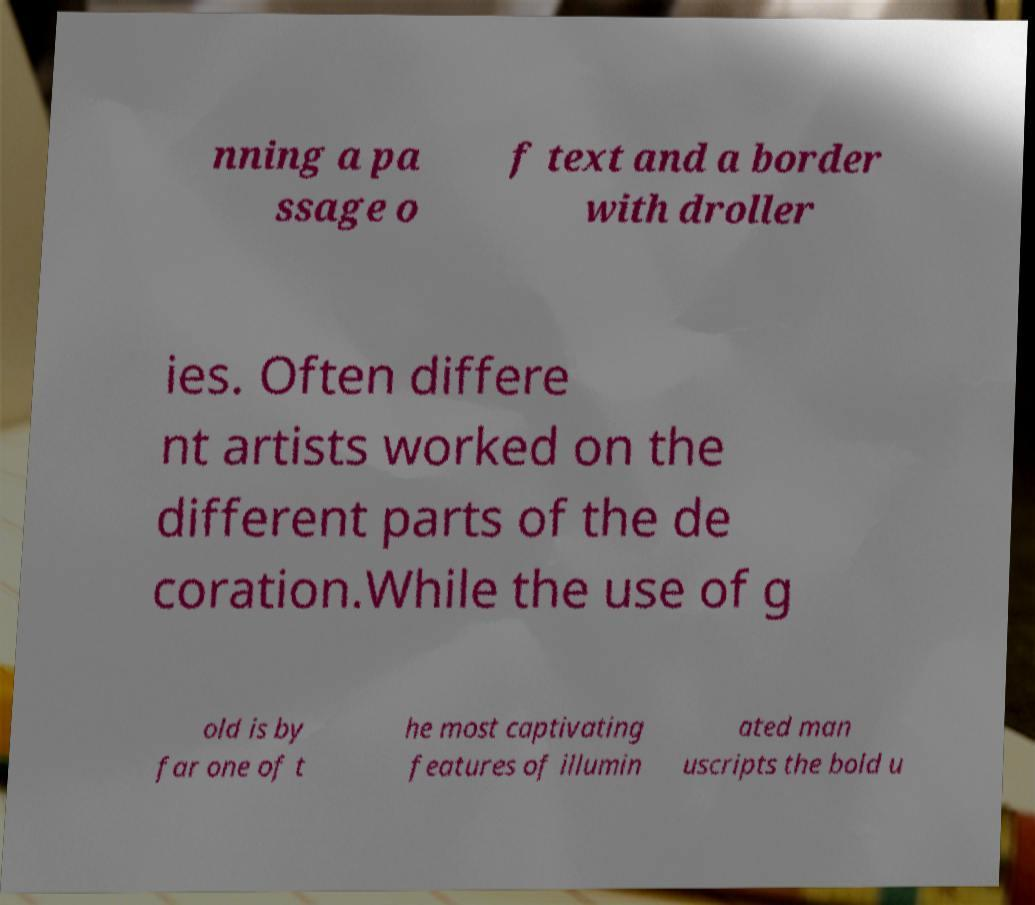What messages or text are displayed in this image? I need them in a readable, typed format. nning a pa ssage o f text and a border with droller ies. Often differe nt artists worked on the different parts of the de coration.While the use of g old is by far one of t he most captivating features of illumin ated man uscripts the bold u 